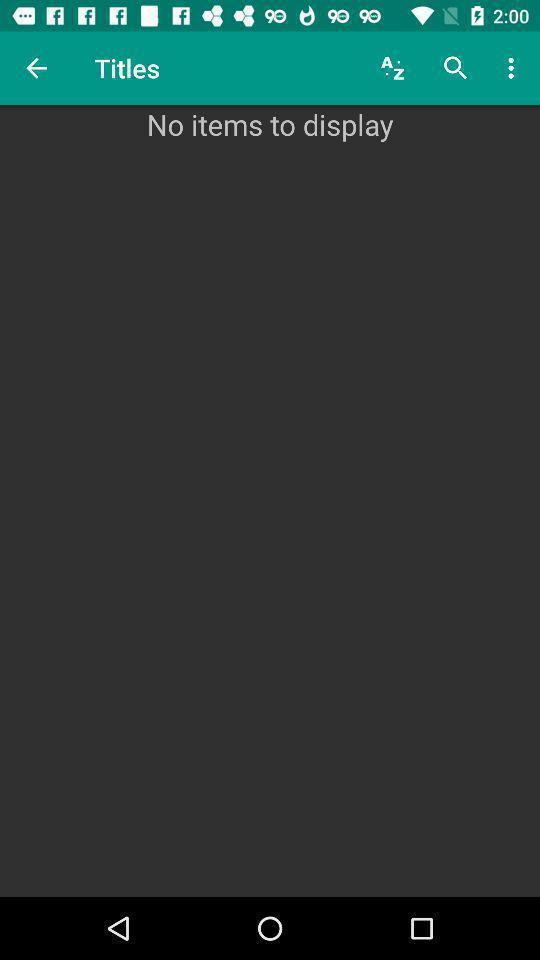What is the overall content of this screenshot? Social app for displaying titles. 